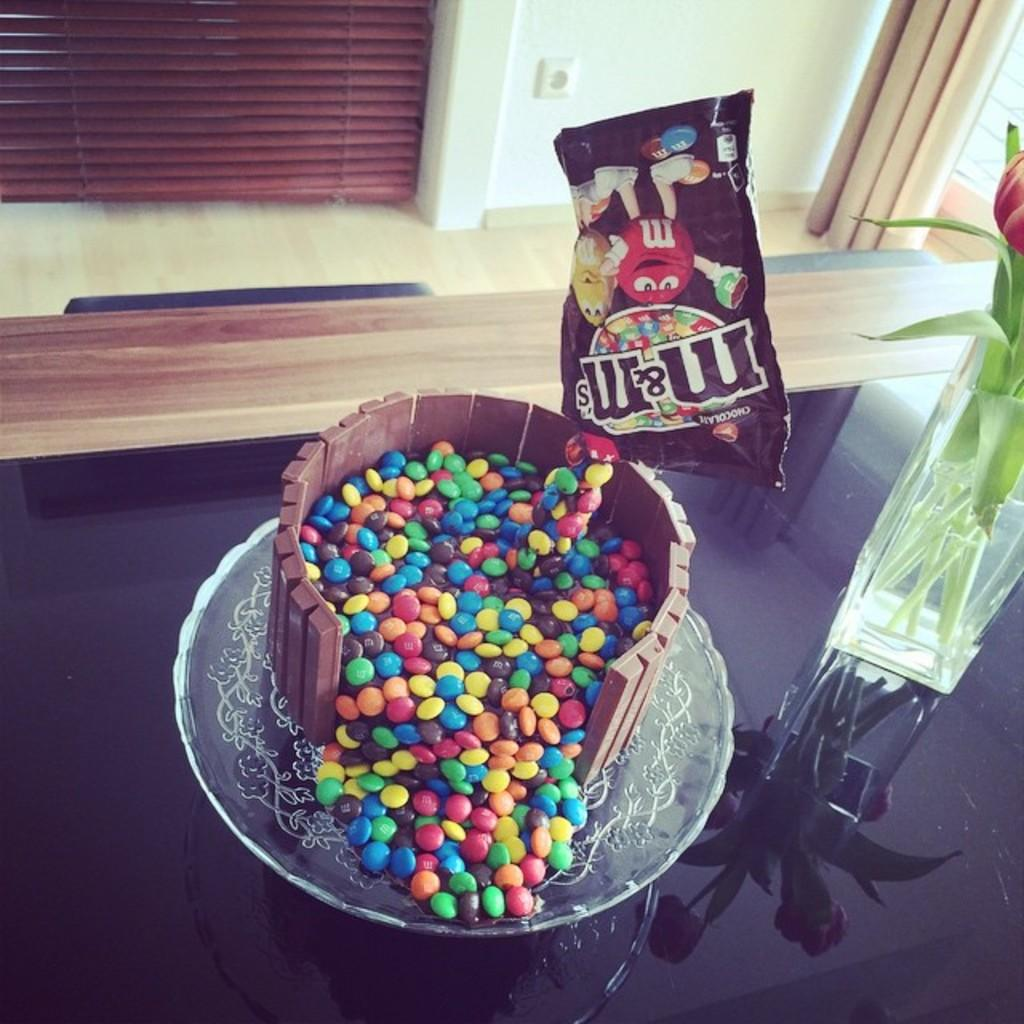What is on the glass surface in the image? There is a vase with stems, a packet, and a plate on the glass surface. What is on the plate? There are sweets in different colors on the plate. What can be seen in the background of the image? There is a curtain and a wall in the background. How does the harmony between the sweets and the fork in the image contribute to the overall aesthetic? There is no fork present in the image, so it is not possible to discuss the harmony between the sweets and the fork. 